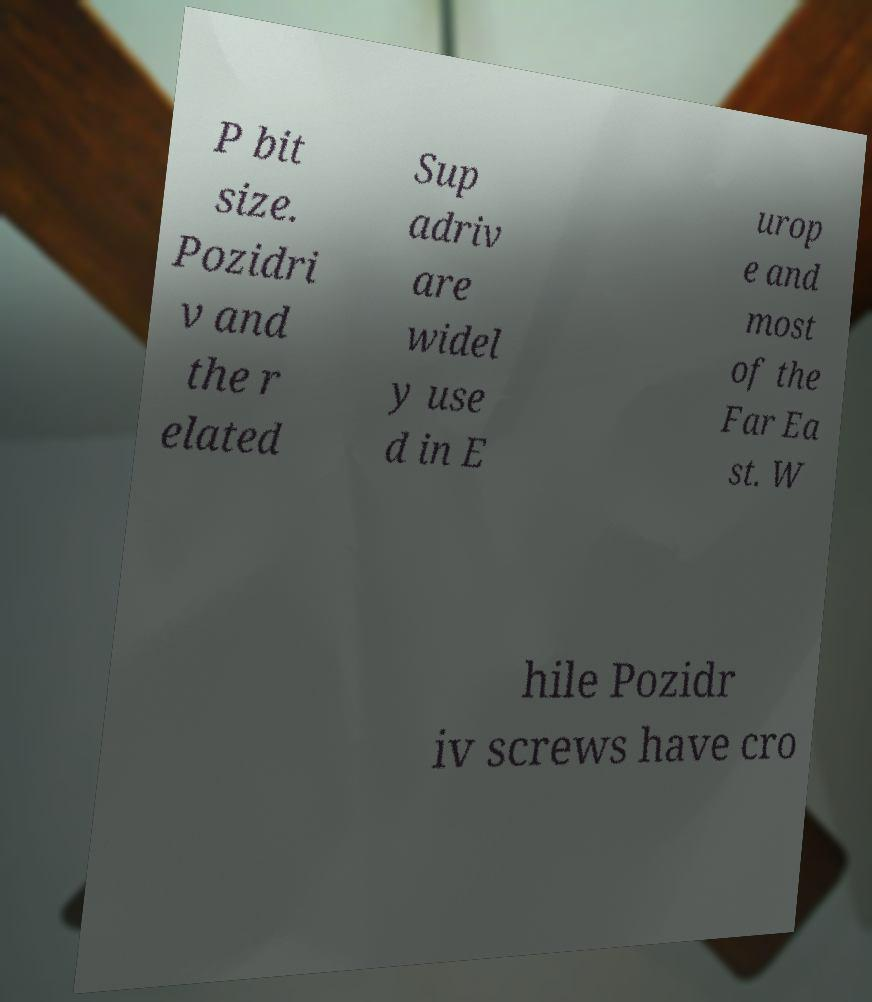Can you read and provide the text displayed in the image?This photo seems to have some interesting text. Can you extract and type it out for me? P bit size. Pozidri v and the r elated Sup adriv are widel y use d in E urop e and most of the Far Ea st. W hile Pozidr iv screws have cro 